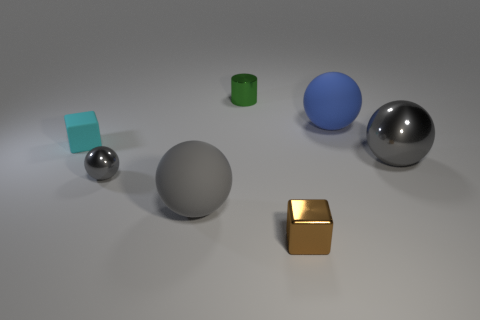Subtract all green blocks. How many gray spheres are left? 3 Add 2 matte objects. How many objects exist? 9 Subtract all balls. How many objects are left? 3 Subtract all large blue things. Subtract all green metal cylinders. How many objects are left? 5 Add 6 tiny brown metallic objects. How many tiny brown metallic objects are left? 7 Add 2 cyan things. How many cyan things exist? 3 Subtract 0 green spheres. How many objects are left? 7 